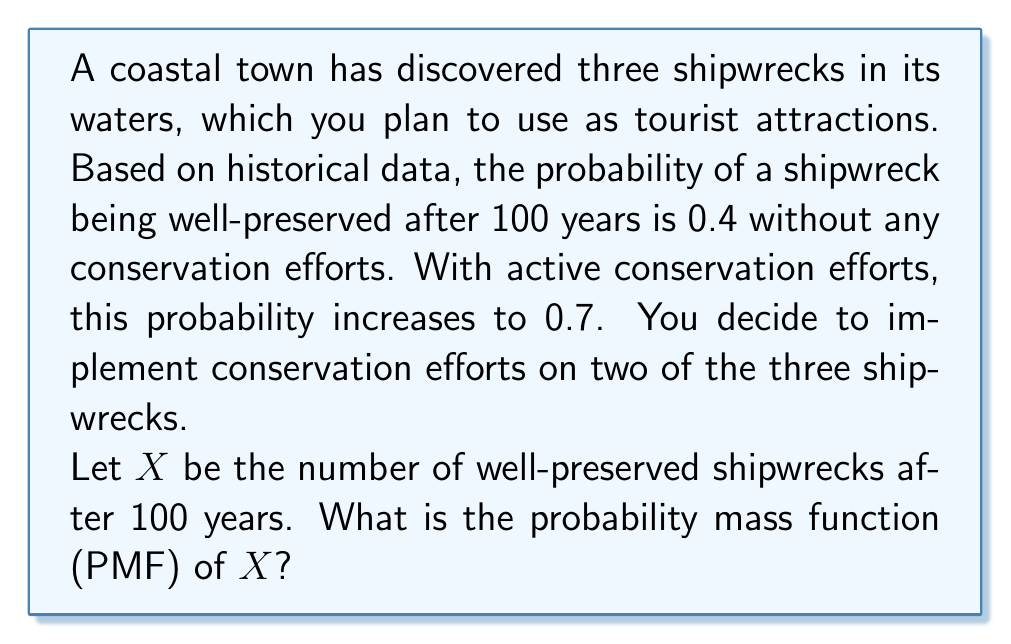Teach me how to tackle this problem. To solve this problem, we'll use the concept of Binomial distribution and the law of total probability.

1) We have two groups of shipwrecks:
   - 2 shipwrecks with conservation efforts (probability of preservation = 0.7)
   - 1 shipwreck without conservation efforts (probability of preservation = 0.4)

2) Let's define events:
   - $A$: The shipwreck without conservation is preserved
   - $B_i$: Exactly $i$ shipwrecks with conservation are preserved ($i = 0, 1, 2$)

3) We need to calculate $P(X = k)$ for $k = 0, 1, 2, 3$

4) Using the law of total probability:
   $P(X = k) = P(X = k | A)P(A) + P(X = k | A^c)P(A^c)$

5) Probabilities for $A$ and $A^c$:
   $P(A) = 0.4$, $P(A^c) = 0.6$

6) For the two shipwrecks with conservation, we use Binomial distribution:
   $P(B_i) = \binom{2}{i}(0.7)^i(0.3)^{2-i}$

7) Now, let's calculate for each $k$:

   For $k = 0$:
   $P(X = 0) = P(B_0)P(A^c) = \binom{2}{0}(0.3)^2 \cdot 0.6 = 0.054$

   For $k = 1$:
   $P(X = 1) = P(B_1)P(A^c) + P(B_0)P(A) = \binom{2}{1}(0.7)(0.3) \cdot 0.6 + \binom{2}{0}(0.3)^2 \cdot 0.4 = 0.306$

   For $k = 2$:
   $P(X = 2) = P(B_2)P(A^c) + P(B_1)P(A) = \binom{2}{2}(0.7)^2 \cdot 0.6 + \binom{2}{1}(0.7)(0.3) \cdot 0.4 = 0.442$

   For $k = 3$:
   $P(X = 3) = P(B_2)P(A) = \binom{2}{2}(0.7)^2 \cdot 0.4 = 0.196$

8) Therefore, the PMF of $X$ is:

   $$P(X = k) = \begin{cases}
   0.054 & \text{if } k = 0 \\
   0.306 & \text{if } k = 1 \\
   0.442 & \text{if } k = 2 \\
   0.196 & \text{if } k = 3 \\
   0 & \text{otherwise}
   \end{cases}$$
Answer: The probability mass function (PMF) of $X$ is:

$$P(X = k) = \begin{cases}
0.054 & \text{if } k = 0 \\
0.306 & \text{if } k = 1 \\
0.442 & \text{if } k = 2 \\
0.196 & \text{if } k = 3 \\
0 & \text{otherwise}
\end{cases}$$ 